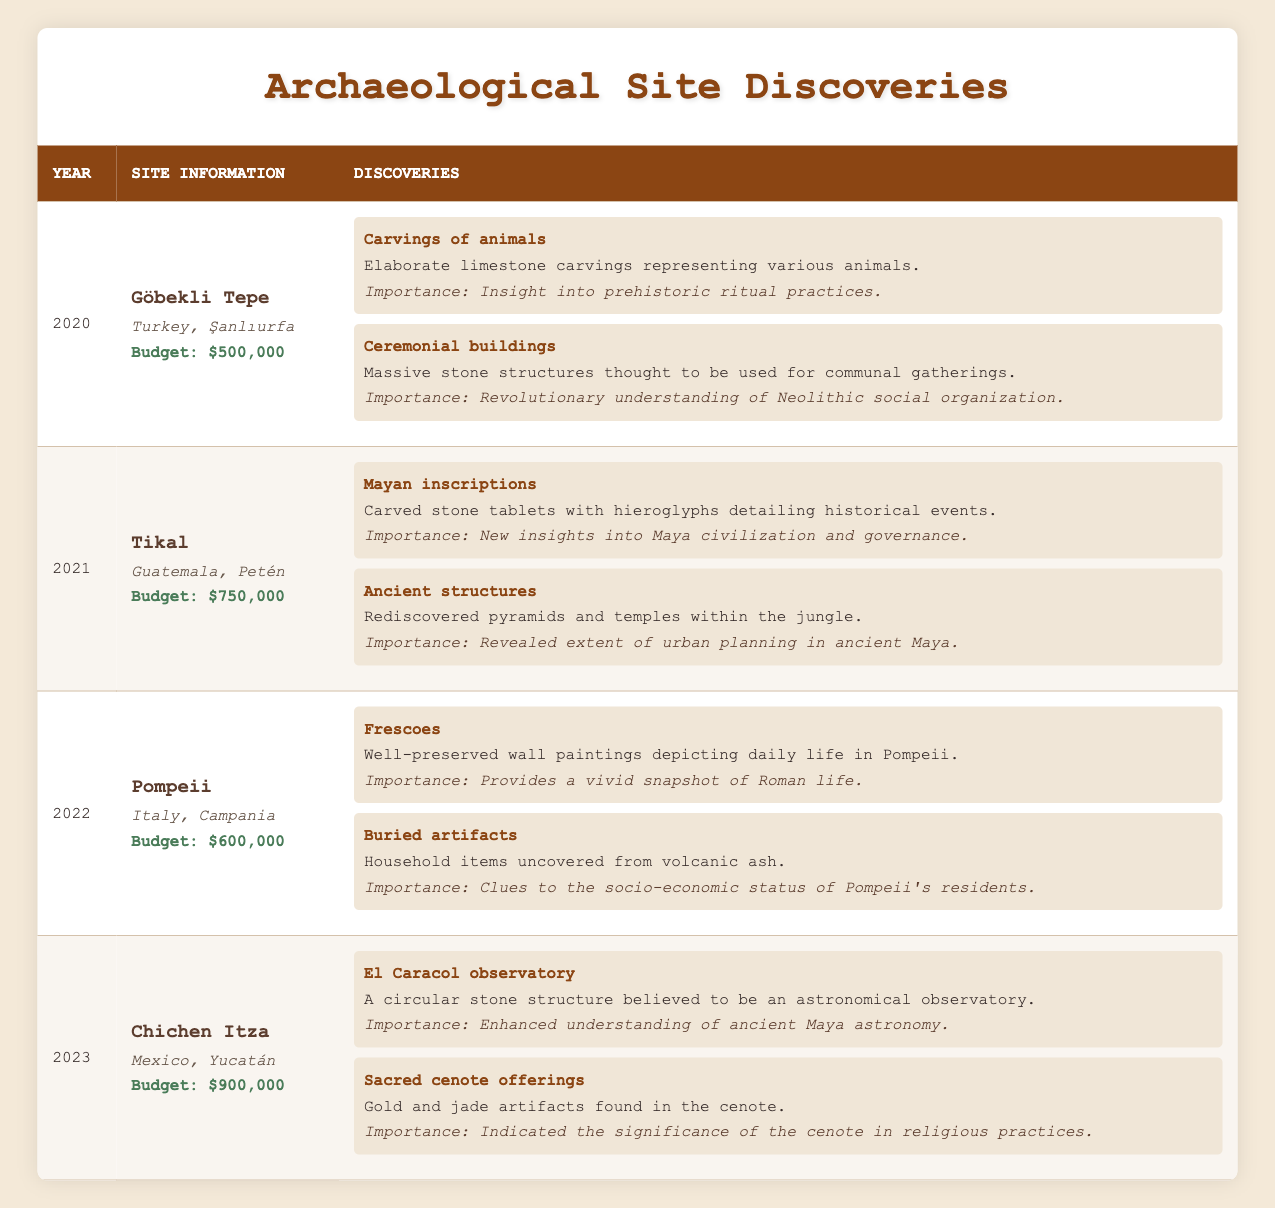What archaeological site was discovered in 2021? According to the table, the site discovered in 2021 is Tikal.
Answer: Tikal How much was the budget for archaeological discoveries in 2022? From the table, the budget for the archaeological discoveries in 2022 was $600,000.
Answer: $600,000 Did any discoveries in 2020 include ancient structures? Looking at the details for 2020, there are no mentions of ancient structures in the discoveries. The artifacts listed were carvings of animals and ceremonial buildings.
Answer: No What was the total budget for discoveries from 2020 to 2023 combined? The budgets for each year are: 2020 ($500,000), 2021 ($750,000), 2022 ($600,000), and 2023 ($900,000). Adding these amounts gives $500,000 + $750,000 + $600,000 + $900,000 = $2,750,000.
Answer: $2,750,000 Which site had the highest budget for discoveries, and what was that budget? Comparing the budgets from each year, 2023 had the highest budget of $900,000 for Chichen Itza.
Answer: Chichen Itza, $900,000 Which discoveries in 2023 indicated the significance of the cenote in religious practices? The discoveries in 2023 that indicated the significance of the cenote in religious practices were the sacred cenote offerings, which included gold and jade artifacts.
Answer: Sacred cenote offerings What is the average budget for archaeological sites discovered between 2020 and 2023? The budgets from 2020 to 2023 are $500,000, $750,000, $600,000, and $900,000. To find the average, add these budgets to get a total of $2,750,000 and then divide by the number of years, which is 4. So, $2,750,000 / 4 = $687,500.
Answer: $687,500 Were there any discoveries at Pompeii that provide information about socio-economic status? Yes, one of the discoveries at Pompeii was buried artifacts, which provide clues to the socio-economic status of Pompeii's residents.
Answer: Yes How many types of discoveries were reported for the site of Tikal, and what were they? Tikal reported two types of discoveries: Mayan inscriptions and ancient structures.
Answer: Two types: Mayan inscriptions, ancient structures 